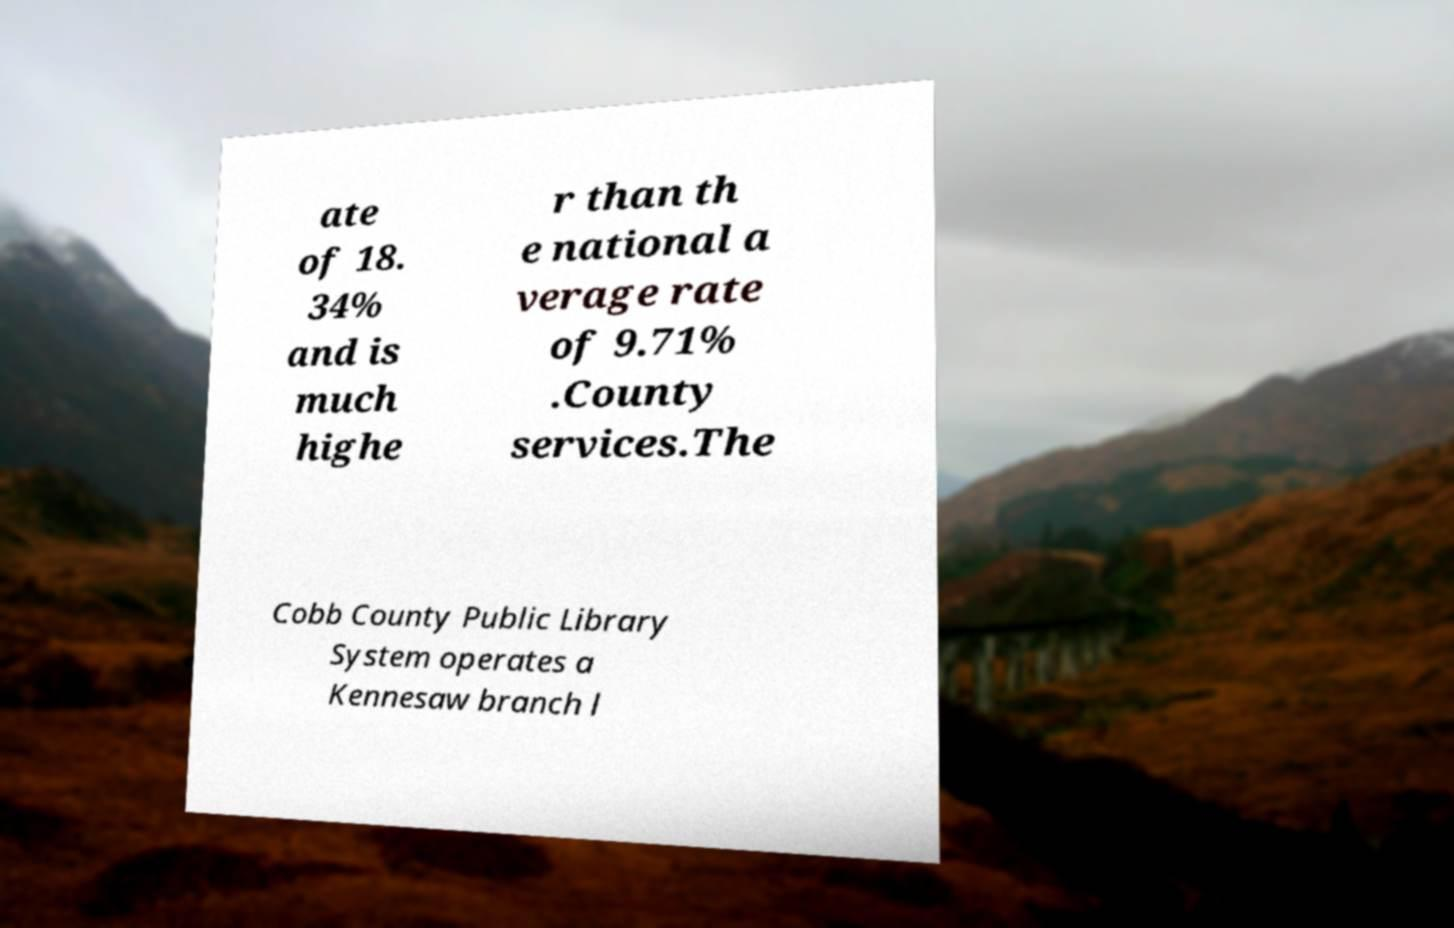Can you accurately transcribe the text from the provided image for me? ate of 18. 34% and is much highe r than th e national a verage rate of 9.71% .County services.The Cobb County Public Library System operates a Kennesaw branch l 